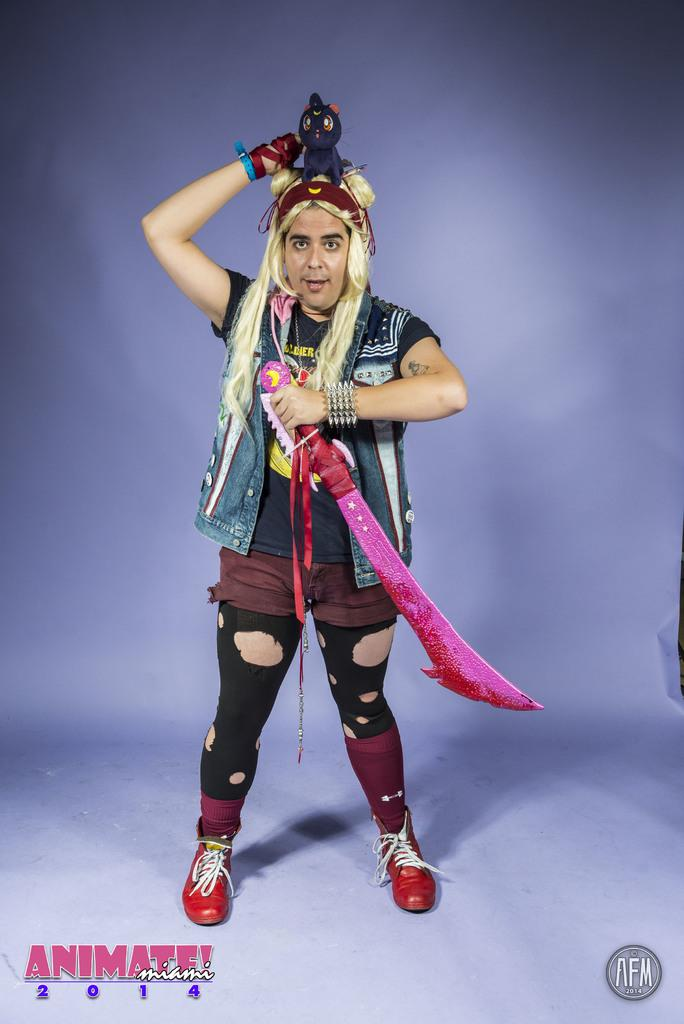What is the person in the image doing? The person is standing in the image. What object is the person holding in the image? The person is holding a sword and a toy in his hand. What question is the person asking in the image? There is no indication in the image that the person is asking a question. 